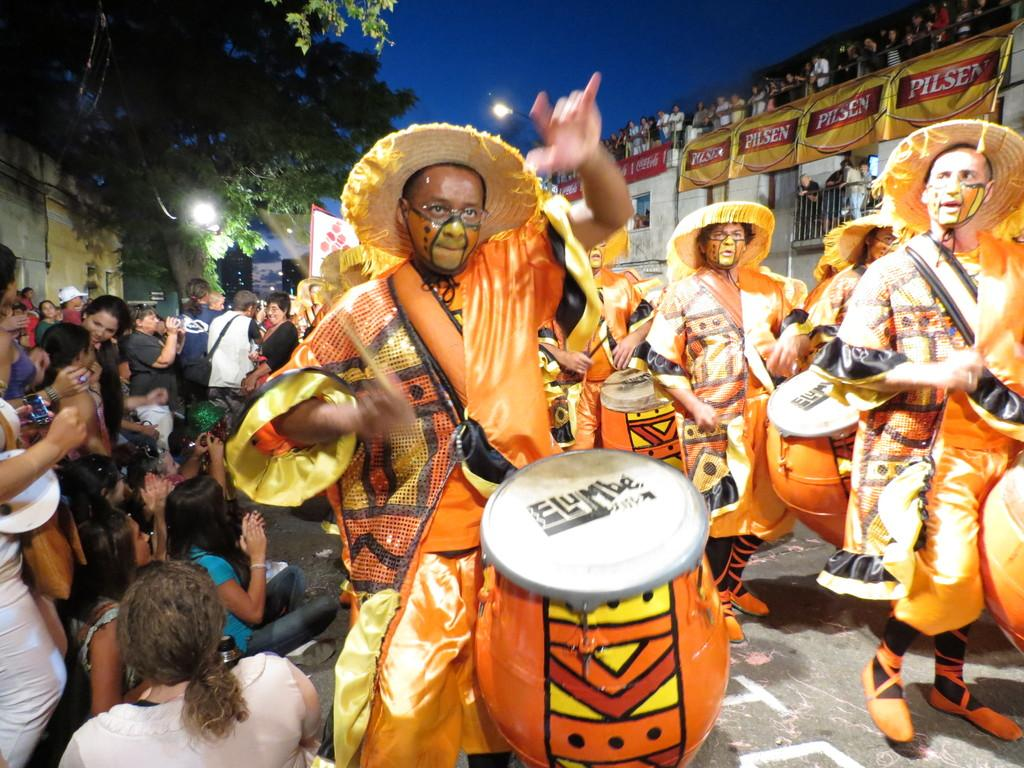What are the people in the image doing? The people in the image are playing musical drums. Where are some of the people located in the image? Some people are standing above a building. What type of natural elements can be seen in the image? Trees are visible in the image. What else can be seen in the image besides the people and trees? There are lights visible in the image. How many people are present in the image? There is a group of people present. What type of orange tree can be seen in the image? There is no orange tree present in the image. What type of shade is provided by the trees in the image? The trees in the image do not provide any shade, as they are not close enough to the people or objects to cast a shadow. 